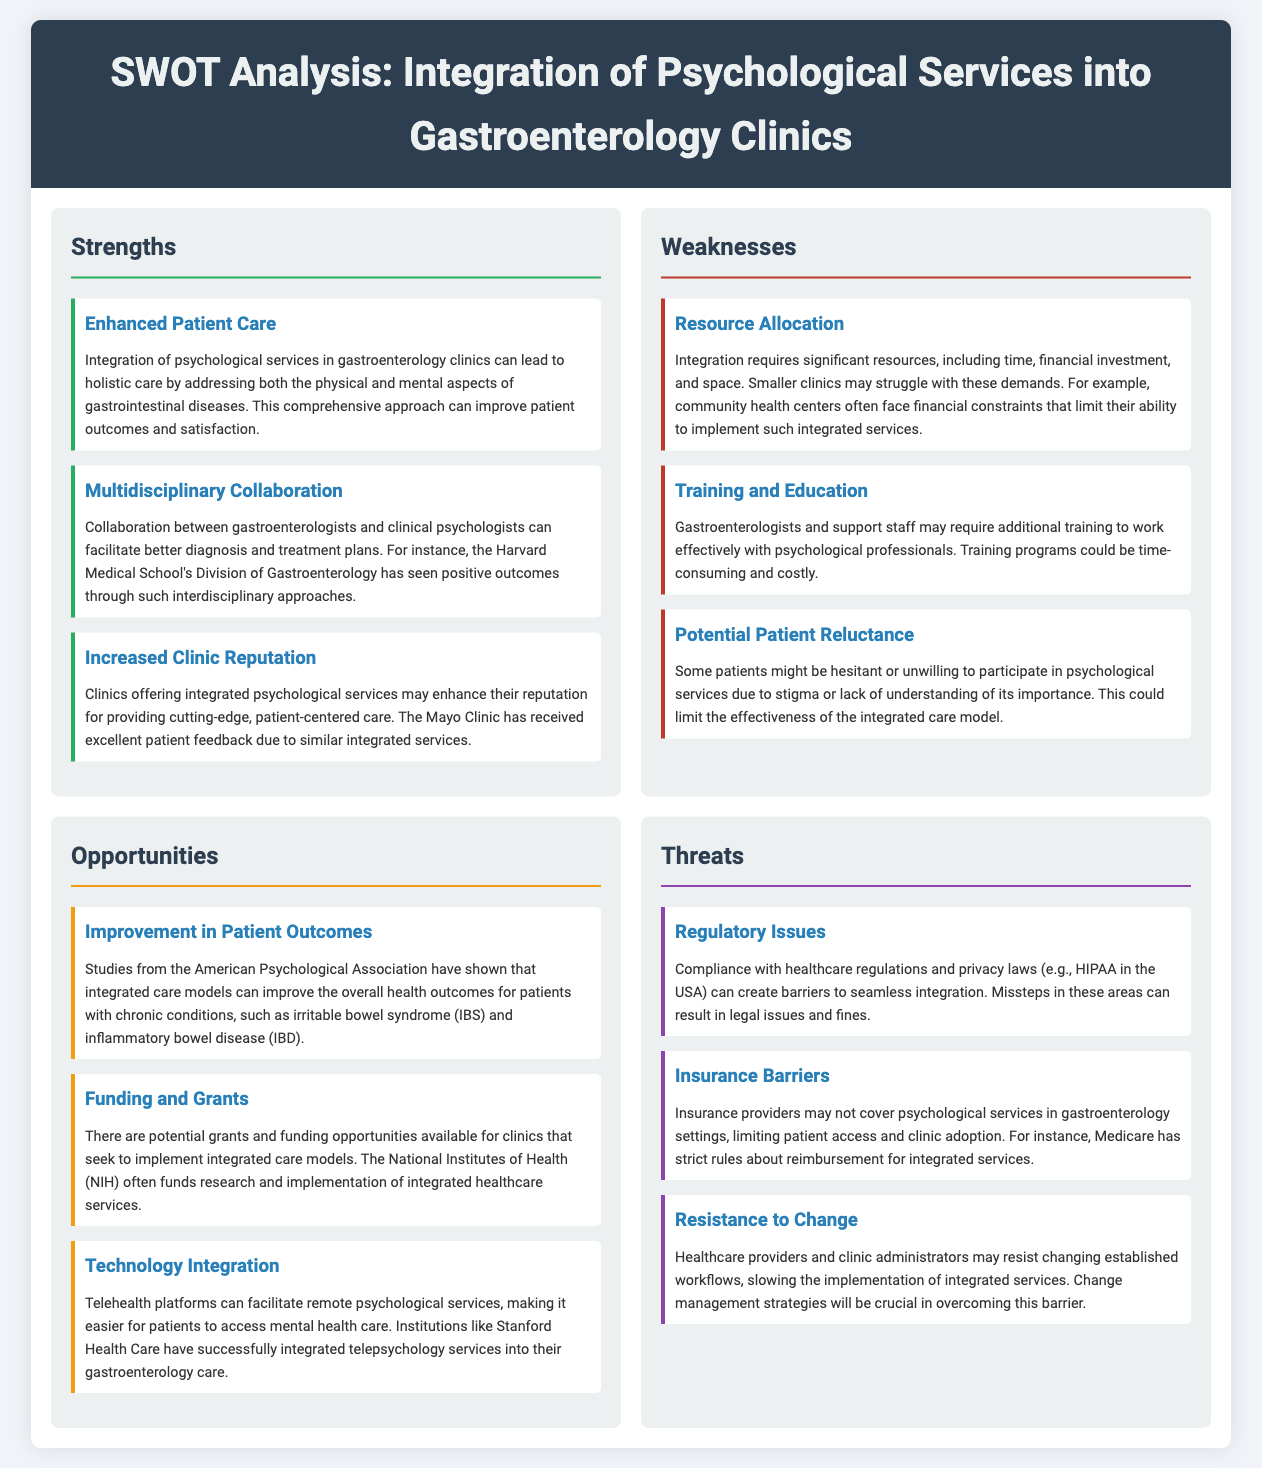What is the title of the document? The title of the document is provided in the header section, which states the main topic of the analysis.
Answer: SWOT Analysis: Integration of Psychological Services into Gastroenterology Clinics How many strengths are listed in the analysis? The document provides a section for strengths, which includes three detailed items.
Answer: 3 What is one of the weaknesses mentioned? The weaknesses section lists several challenges associated with the integration of psychological services, highlighting specific issues faced by clinics.
Answer: Resource Allocation Which opportunity focuses on technology? The opportunities section includes technological advancements that can aid in providing integrated services to patients.
Answer: Technology Integration What is a threat related to healthcare regulations? The threats section discusses various challenges, including compliance with regulations, which affects the implementation of services.
Answer: Regulatory Issues 